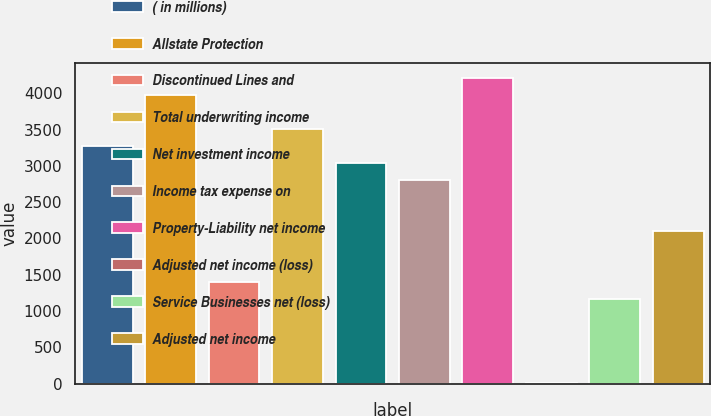<chart> <loc_0><loc_0><loc_500><loc_500><bar_chart><fcel>( in millions)<fcel>Allstate Protection<fcel>Discontinued Lines and<fcel>Total underwriting income<fcel>Net investment income<fcel>Income tax expense on<fcel>Property-Liability net income<fcel>Adjusted net income (loss)<fcel>Service Businesses net (loss)<fcel>Adjusted net income<nl><fcel>3276.6<fcel>3978.3<fcel>1405.4<fcel>3510.5<fcel>3042.7<fcel>2808.8<fcel>4212.2<fcel>2<fcel>1171.5<fcel>2107.1<nl></chart> 